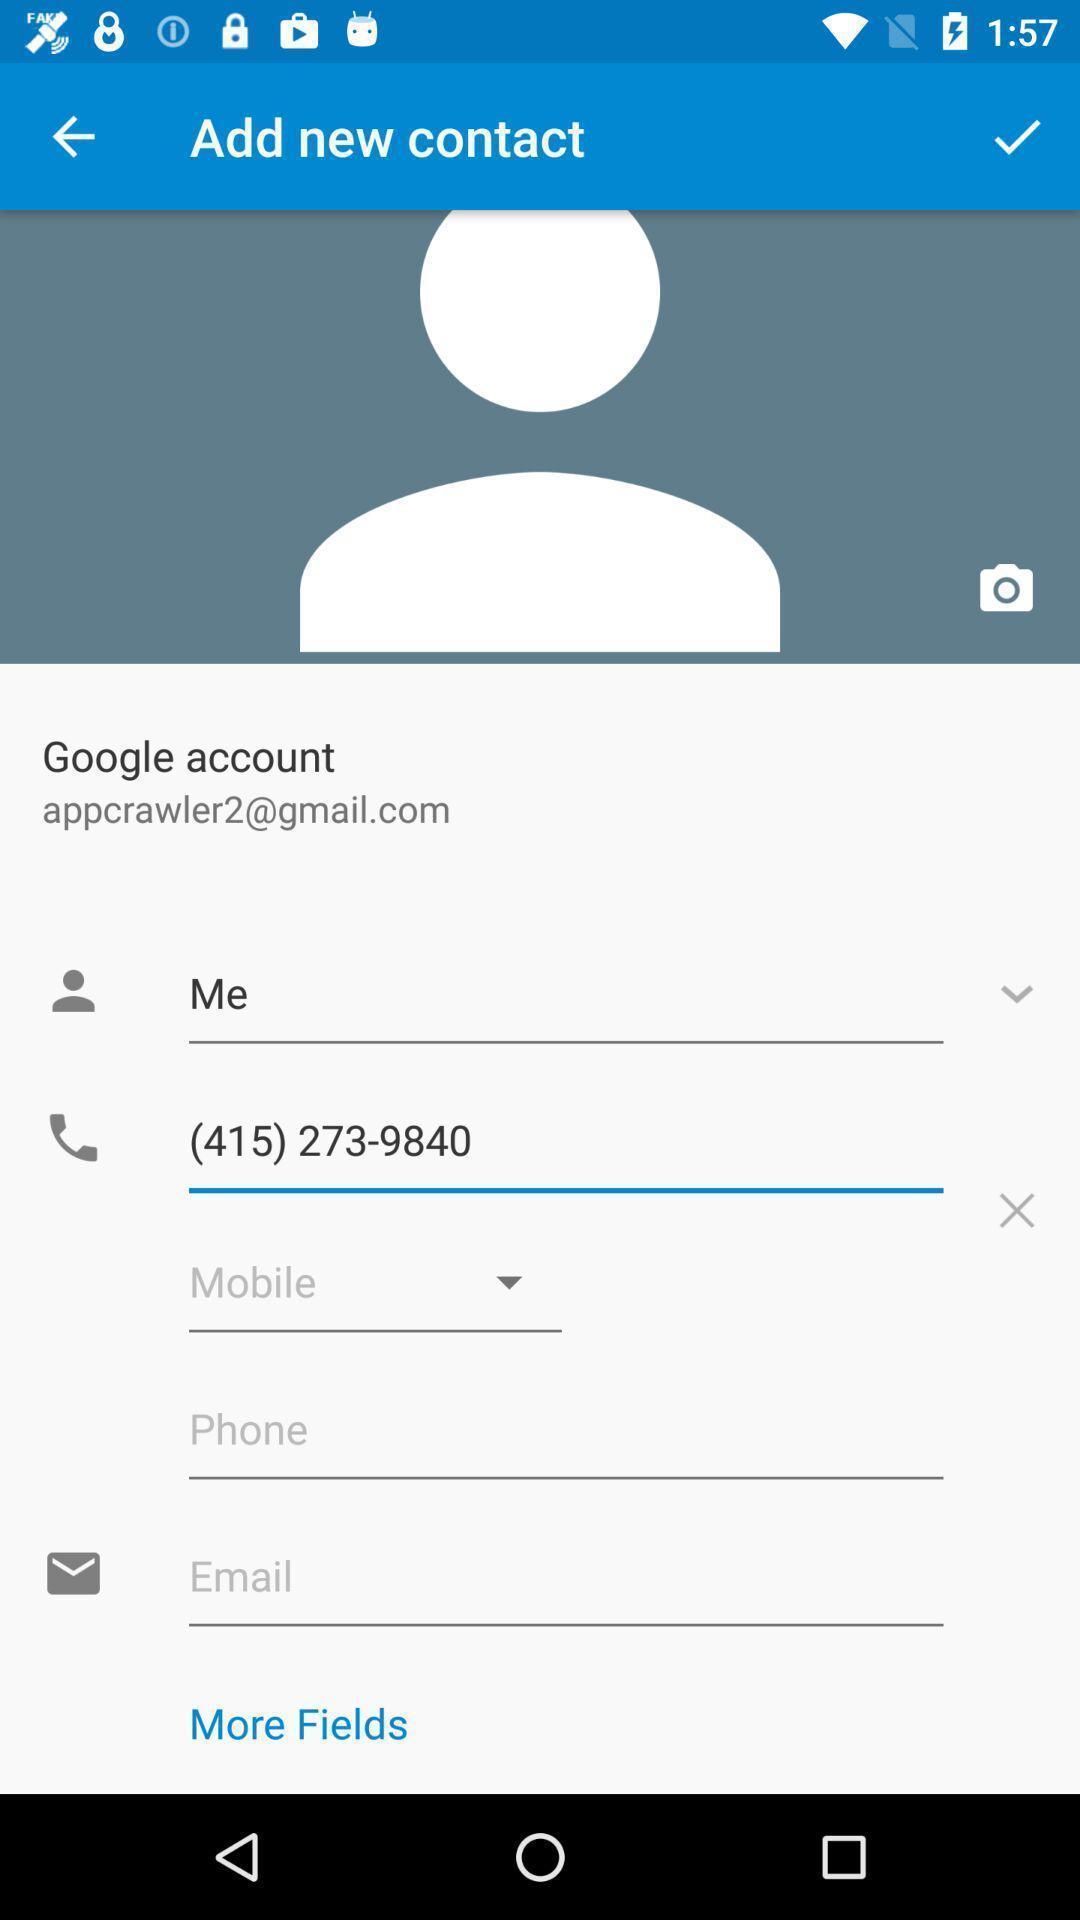Summarize the information in this screenshot. Screen shows add contact details in a call app. 